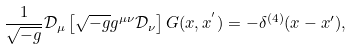<formula> <loc_0><loc_0><loc_500><loc_500>\frac { 1 } { \sqrt { - g } } { \mathcal { D } } _ { \mu } \left [ \sqrt { - g } g ^ { \mu \nu } { \mathcal { D } } _ { \nu } \right ] G ( x , x ^ { ^ { \prime } } ) = - \delta ^ { ( 4 ) } ( x - x ^ { \prime } ) ,</formula> 